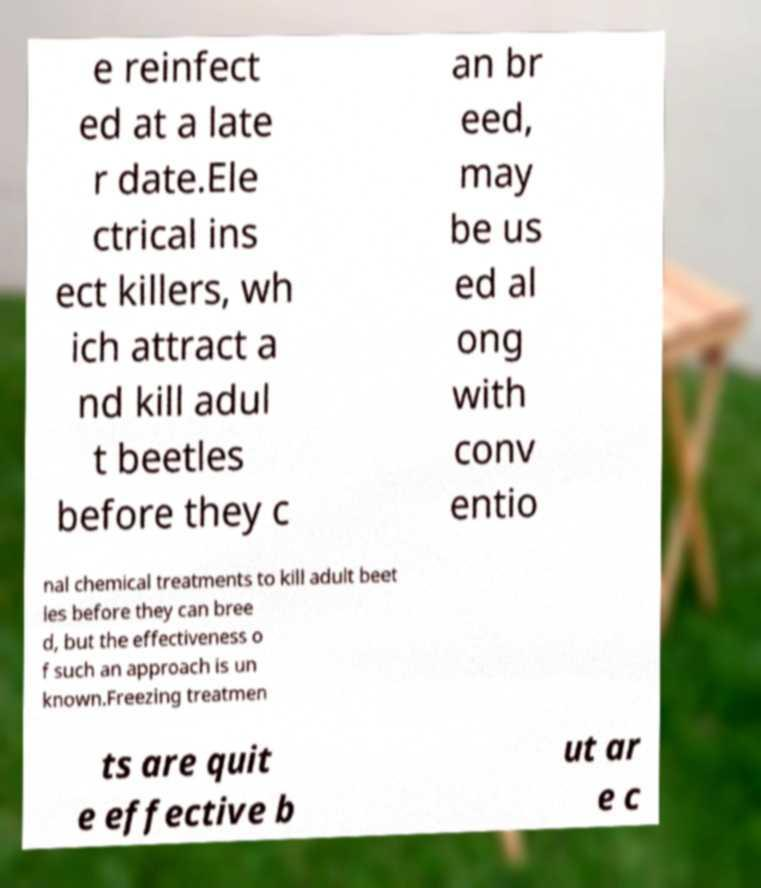Could you extract and type out the text from this image? e reinfect ed at a late r date.Ele ctrical ins ect killers, wh ich attract a nd kill adul t beetles before they c an br eed, may be us ed al ong with conv entio nal chemical treatments to kill adult beet les before they can bree d, but the effectiveness o f such an approach is un known.Freezing treatmen ts are quit e effective b ut ar e c 